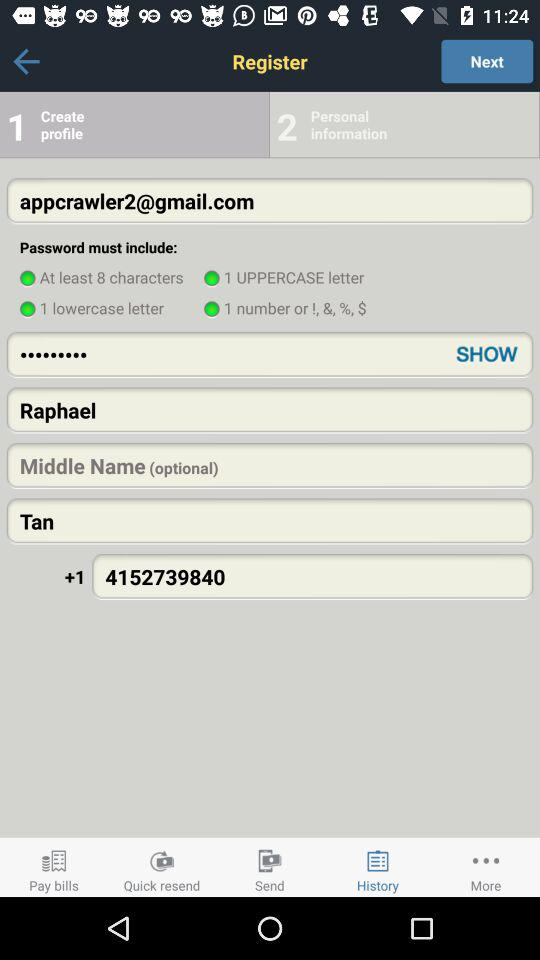What is the user name? The user name is Raphael Tan. 